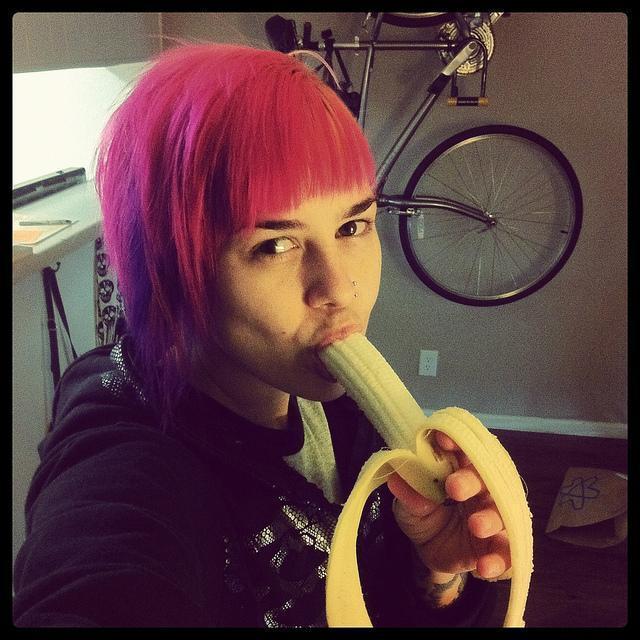Is the statement "The bicycle is behind the banana." accurate regarding the image?
Answer yes or no. Yes. Does the caption "The banana is inside the person." correctly depict the image?
Answer yes or no. Yes. 